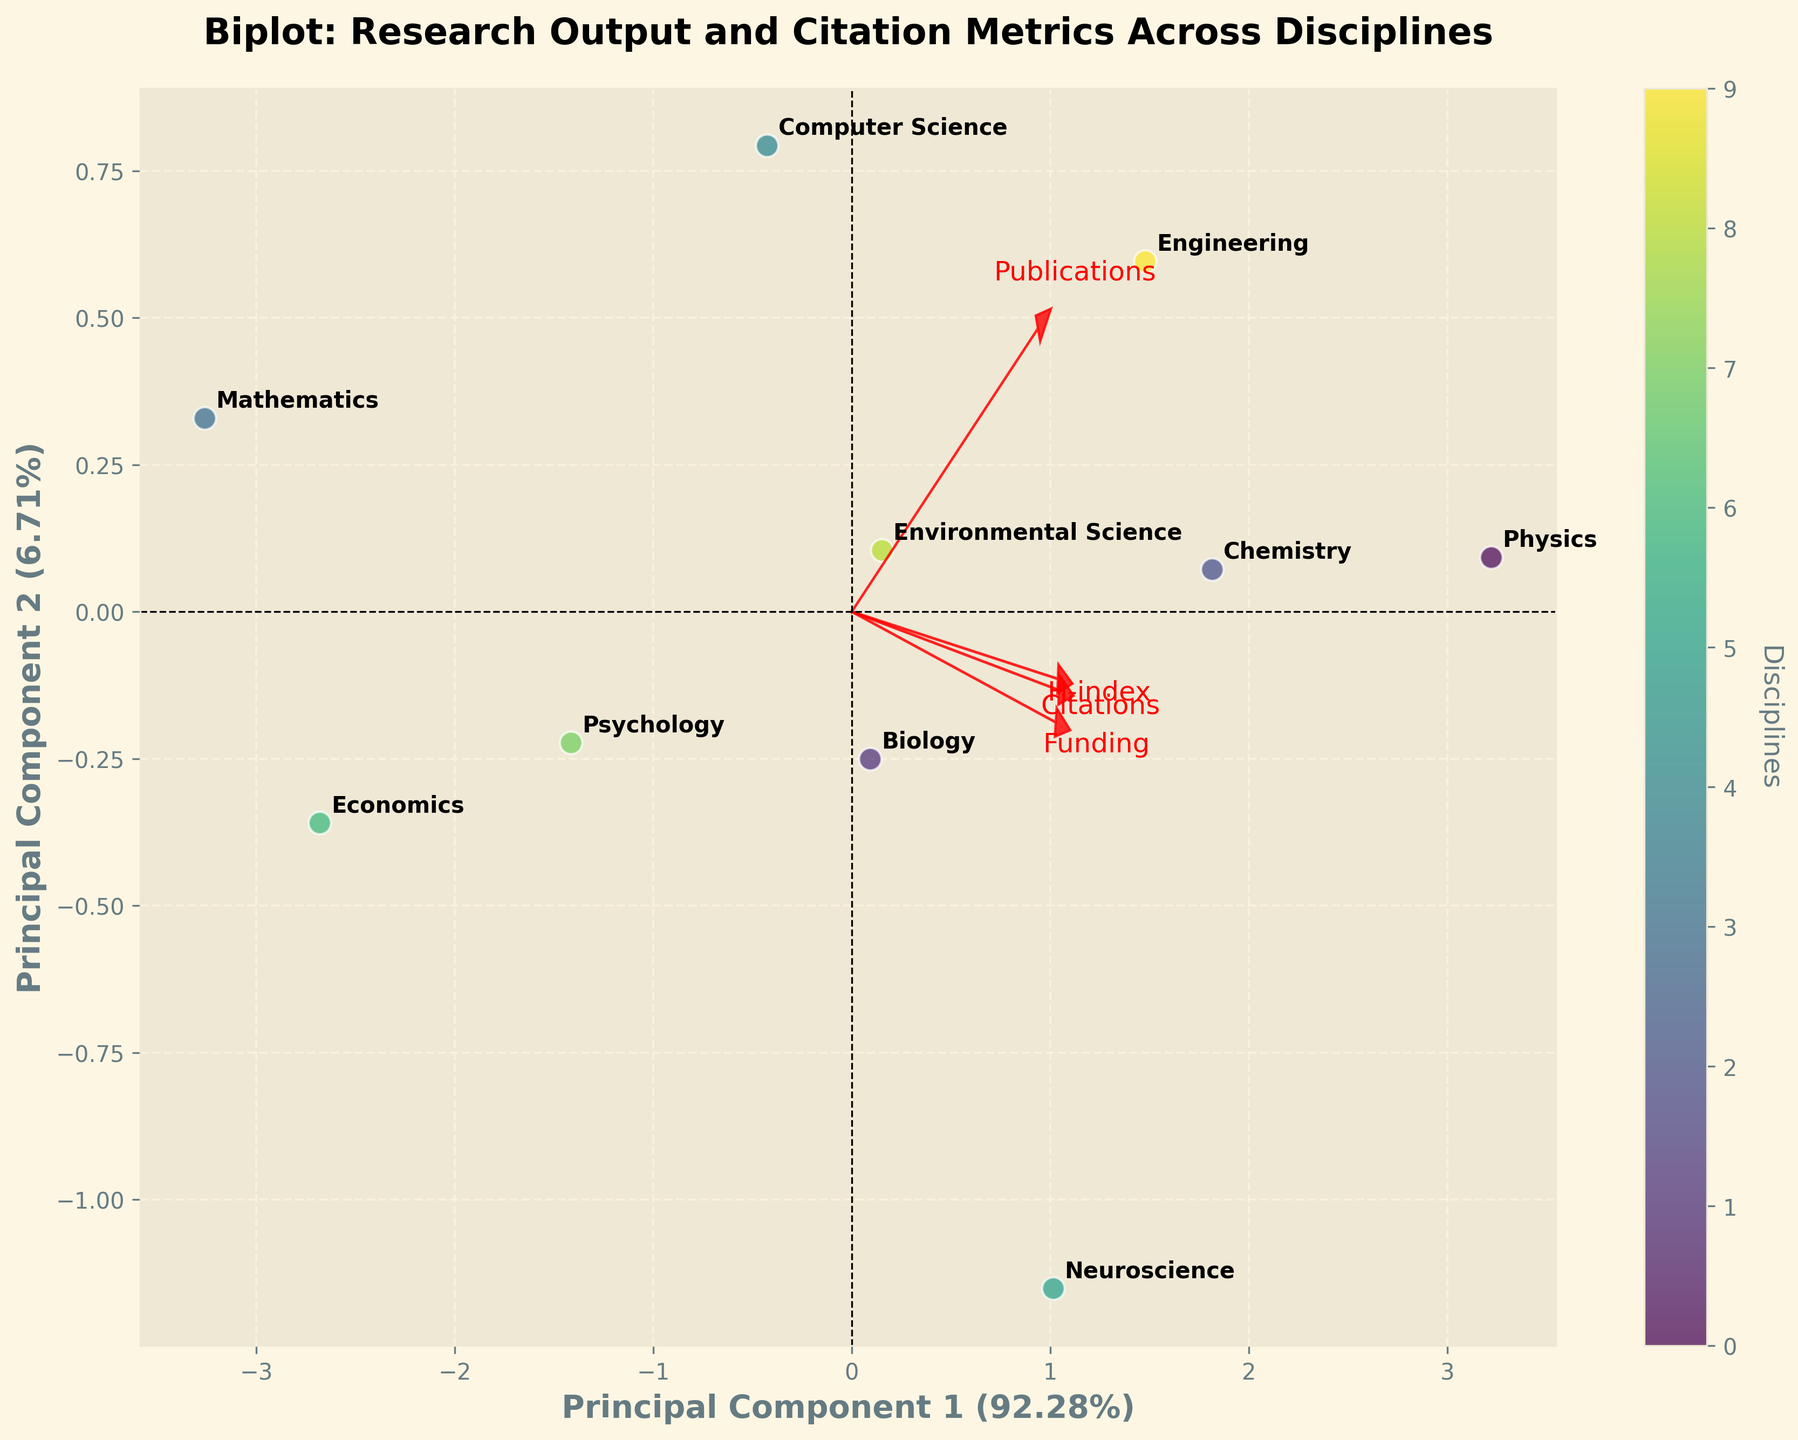How many disciplines are represented in the plot? The plot includes all the listed disciplines, each represented by a distinct point. By counting the annotated labels, we see each discipline is represented once in the plot.
Answer: 10 Which two disciplines are positioned closest to each other in the biplot? By observing the plot, identifying two points that are closely positioned involves looking at the proximities of the labeled points. Psychology and Environmental Science are placed closest to each other.
Answer: Psychology and Environmental Science What is the explained variance of Principal Component 1? The explained variance can be found on the label of the x-axis. According to the figure, Principal Component 1 explains 48.12% of the variance.
Answer: 48.12% Which discipline has the highest value in the first principal component? To determine which discipline has the highest value in Principal Component 1, look at the point that is placed furthest to the right on the x-axis. The discipline furthest to the right is Physics.
Answer: Physics Which factors contribute most to the second principal component? The factors’ contributions can be inferred from the length and direction of the arrows for each factor in relation to the second component (y-axis). ‘H-index’ and ‘Funding’ seem to contribute significantly to the second principal component as indicated by the arrow orientations.
Answer: H-index and Funding How many disciplines are positioned in the positive quadrant of both principal components? Points in the positive quadrant of both principal components appear in the top-right area of the plot. By counting the labeled points in this area, we see that there are four disciplines positioned there.
Answer: 4 Identify the disciplines with high citation metrics but relatively lower publications from the biplot. Disciplines with high citations but relatively lower publication counts will have high position along the 'Citations' arrow but lower along the 'Publications' arrow. Neuroscience and Biology fit this description based on the plot’s position.
Answer: Neuroscience and Biology Which factor correlates most strongly with Principal Component 1? The strength of correlation is indicated by the arrow lengths and alignments along Principal Component 1 (x-axis). ‘Citations’ has the longest arrow along this direction, indicating the strongest correlation.
Answer: Citations Can we infer which discipline has a better overall research output directly from their position in the plot? The overall research output can be inferred by considering both principal components. Disciplines positioned farthest from the origin on both components generally represent better overall output. Physics, positioned farthest from the origin, suggests better overall research output.
Answer: Physics What is the relationship between the publications and citations based on the biplot? The relationship can be understood by observing the directions of the respective arrows for ‘Publications’ and ‘Citations’. Since both arrows point in roughly the same direction, there is a positive correlation between publications and citations.
Answer: Positive correlation 